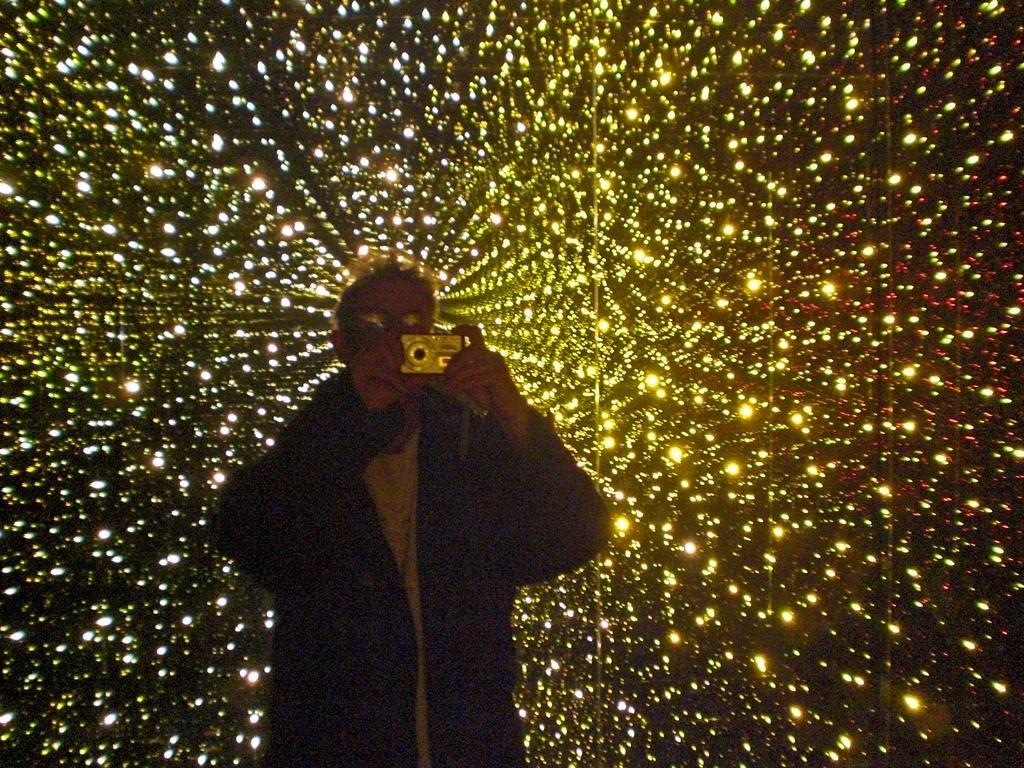Could you give a brief overview of what you see in this image? This is the picture of a person who is holding the camera and behind there are some lights. 